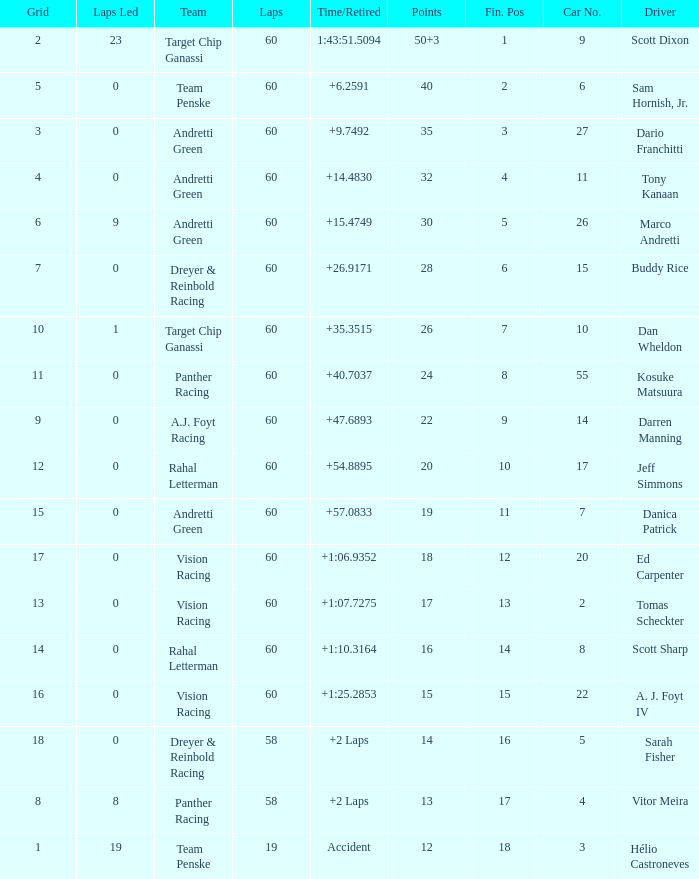What are the laps that result in 18 points? 60.0. Would you be able to parse every entry in this table? {'header': ['Grid', 'Laps Led', 'Team', 'Laps', 'Time/Retired', 'Points', 'Fin. Pos', 'Car No.', 'Driver'], 'rows': [['2', '23', 'Target Chip Ganassi', '60', '1:43:51.5094', '50+3', '1', '9', 'Scott Dixon'], ['5', '0', 'Team Penske', '60', '+6.2591', '40', '2', '6', 'Sam Hornish, Jr.'], ['3', '0', 'Andretti Green', '60', '+9.7492', '35', '3', '27', 'Dario Franchitti'], ['4', '0', 'Andretti Green', '60', '+14.4830', '32', '4', '11', 'Tony Kanaan'], ['6', '9', 'Andretti Green', '60', '+15.4749', '30', '5', '26', 'Marco Andretti'], ['7', '0', 'Dreyer & Reinbold Racing', '60', '+26.9171', '28', '6', '15', 'Buddy Rice'], ['10', '1', 'Target Chip Ganassi', '60', '+35.3515', '26', '7', '10', 'Dan Wheldon'], ['11', '0', 'Panther Racing', '60', '+40.7037', '24', '8', '55', 'Kosuke Matsuura'], ['9', '0', 'A.J. Foyt Racing', '60', '+47.6893', '22', '9', '14', 'Darren Manning'], ['12', '0', 'Rahal Letterman', '60', '+54.8895', '20', '10', '17', 'Jeff Simmons'], ['15', '0', 'Andretti Green', '60', '+57.0833', '19', '11', '7', 'Danica Patrick'], ['17', '0', 'Vision Racing', '60', '+1:06.9352', '18', '12', '20', 'Ed Carpenter'], ['13', '0', 'Vision Racing', '60', '+1:07.7275', '17', '13', '2', 'Tomas Scheckter'], ['14', '0', 'Rahal Letterman', '60', '+1:10.3164', '16', '14', '8', 'Scott Sharp'], ['16', '0', 'Vision Racing', '60', '+1:25.2853', '15', '15', '22', 'A. J. Foyt IV'], ['18', '0', 'Dreyer & Reinbold Racing', '58', '+2 Laps', '14', '16', '5', 'Sarah Fisher'], ['8', '8', 'Panther Racing', '58', '+2 Laps', '13', '17', '4', 'Vitor Meira'], ['1', '19', 'Team Penske', '19', 'Accident', '12', '18', '3', 'Hélio Castroneves']]} 